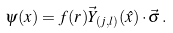Convert formula to latex. <formula><loc_0><loc_0><loc_500><loc_500>\psi ( x ) = f ( r ) \vec { Y } _ { ( j , l ) } ( \hat { x } ) \cdot \vec { \sigma } \, .</formula> 